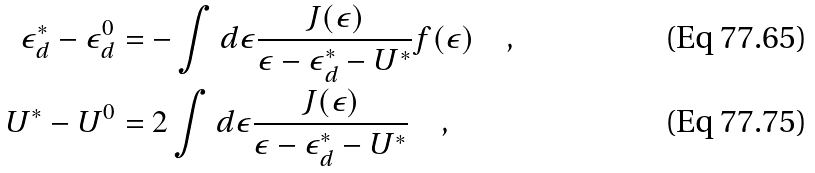Convert formula to latex. <formula><loc_0><loc_0><loc_500><loc_500>\epsilon _ { d } ^ { * } - \epsilon _ { d } ^ { 0 } & = - \int d \epsilon \frac { J ( \epsilon ) } { \epsilon - \epsilon _ { d } ^ { * } - U ^ { * } } f ( \epsilon ) \quad , \\ U ^ { * } - U ^ { 0 } & = 2 \int d \epsilon \frac { J ( \epsilon ) } { \epsilon - \epsilon _ { d } ^ { * } - U ^ { * } } \quad ,</formula> 